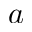Convert formula to latex. <formula><loc_0><loc_0><loc_500><loc_500>a</formula> 